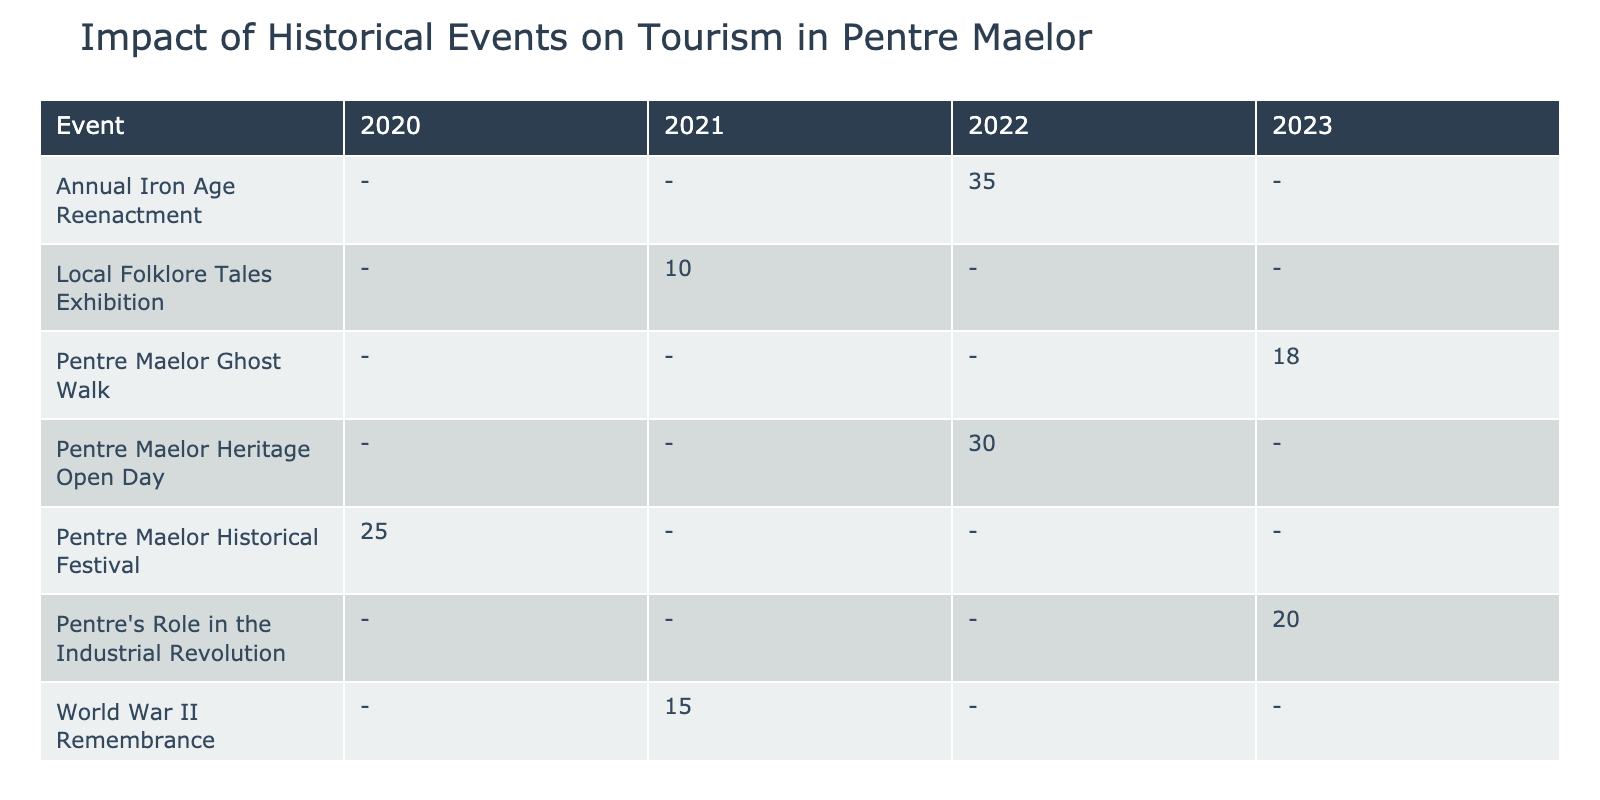What was the visitor increase percentage for the Pentre Maelor Heritage Open Day in 2022? The table shows "Pentre Maelor Heritage Open Day" in the "Event" row and the corresponding year 2022. The "VisitorIncreasePercentage" column for this event indicates a value of 30%.
Answer: 30% Which event had the highest visitor increase percentage? By reviewing the "VisitorIncreasePercentage" column, the "Annual Iron Age Reenactment" in 2022 shows the highest value at 35%.
Answer: 35% Is the main attraction for the World War II Remembrance event Audreys War Memorial? The table lists "World War II Remembrance" under the "Event" column with "Audreys War Memorial" as its "MainAttraction." Thus, this statement is true.
Answer: Yes What is the average visitor increase percentage for events held in 2021? The events in 2021 are "World War II Remembrance" with a percentage of 15% and "Local Folklore Tales Exhibition" with 10%. Their sum is 25%, and dividing this by 2 gives an average of 12.5%.
Answer: 12.5% Which year had events with both an increase percentage below 15%? The table reveals that the "Local Folklore Tales Exhibition" in 2021 at 10% and the "Pentre Maelor Ghost Walk" in 2023 at 18% are below 15%, but there are no events for 2023 under 15%. Therefore, 2021 is the only year with an event below 15%.
Answer: 2021 How many events were held in 2022 and what was their average visitor increase percentage? The events in 2022 were "Pentre Maelor Heritage Open Day" with 30% and "Annual Iron Age Reenactment" at 35%. There are 2 events, so the average visitor increase percentage is (30 + 35)/2 = 32.5%.
Answer: 32.5% Did any event in 2023 report a visitor increase percentage of more than 20%? The table shows that "Pentre's Role in the Industrial Revolution" had a visitor increase of 20%, and the "Pentre Maelor Ghost Walk" had an increase of 18%, both not exceeding 20%. Thus, no event in 2023 recorded an increase over 20%.
Answer: No 